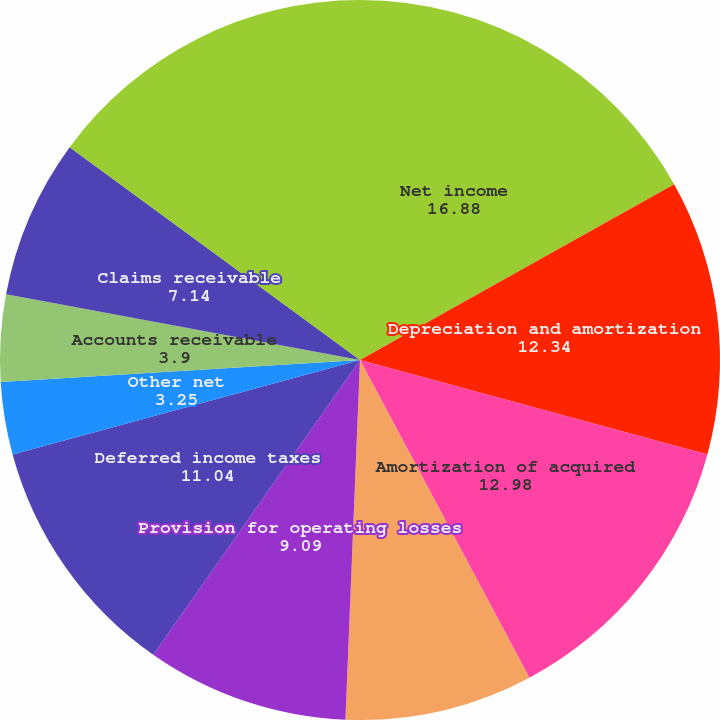Convert chart. <chart><loc_0><loc_0><loc_500><loc_500><pie_chart><fcel>Net income<fcel>Depreciation and amortization<fcel>Amortization of acquired<fcel>Share-based compensation<fcel>Provision for operating losses<fcel>Deferred income taxes<fcel>Other net<fcel>Accounts receivable<fcel>Claims receivable<fcel>Settlement processing assets<nl><fcel>16.88%<fcel>12.34%<fcel>12.98%<fcel>8.44%<fcel>9.09%<fcel>11.04%<fcel>3.25%<fcel>3.9%<fcel>7.14%<fcel>14.93%<nl></chart> 